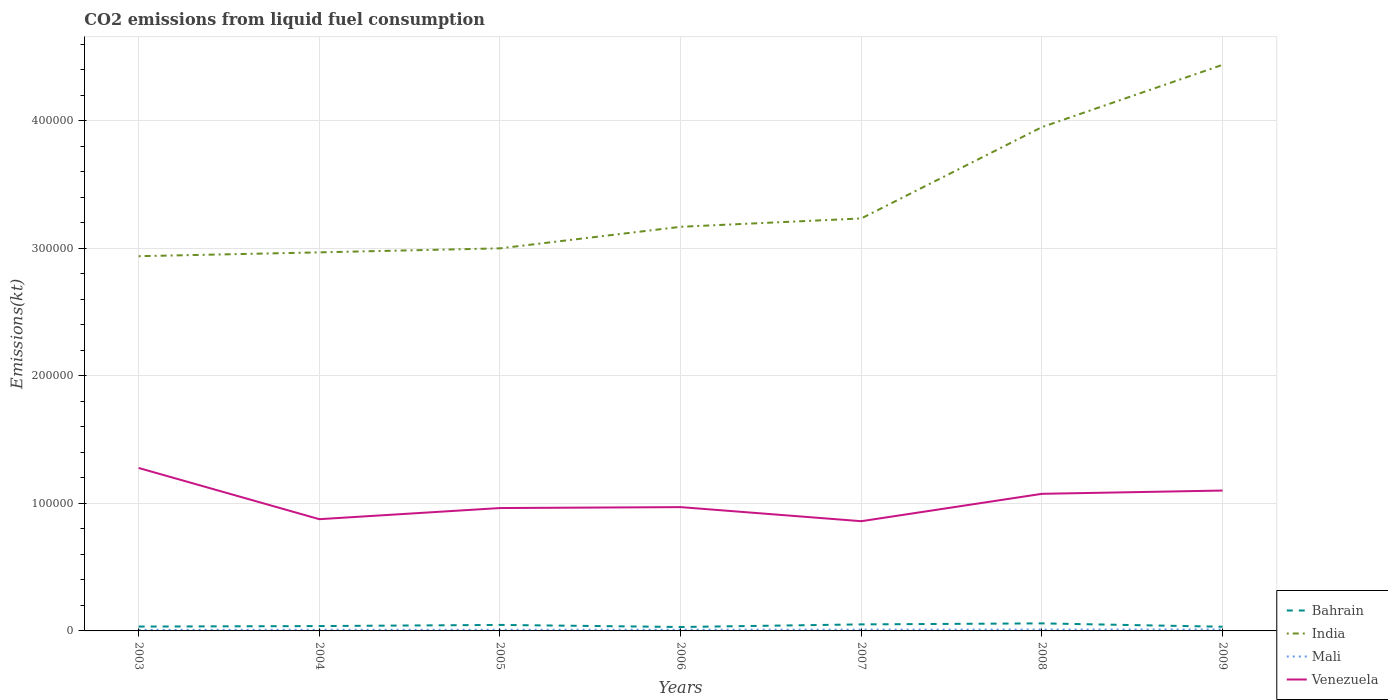How many different coloured lines are there?
Offer a terse response. 4. Does the line corresponding to Bahrain intersect with the line corresponding to Venezuela?
Offer a very short reply. No. Is the number of lines equal to the number of legend labels?
Your answer should be very brief. Yes. Across all years, what is the maximum amount of CO2 emitted in Bahrain?
Make the answer very short. 3072.95. In which year was the amount of CO2 emitted in Venezuela maximum?
Offer a very short reply. 2007. What is the total amount of CO2 emitted in Bahrain in the graph?
Give a very brief answer. 1430.13. What is the difference between the highest and the second highest amount of CO2 emitted in India?
Your answer should be compact. 1.50e+05. What is the difference between the highest and the lowest amount of CO2 emitted in Bahrain?
Provide a succinct answer. 3. Is the amount of CO2 emitted in Mali strictly greater than the amount of CO2 emitted in Venezuela over the years?
Your response must be concise. Yes. How many lines are there?
Keep it short and to the point. 4. How many years are there in the graph?
Provide a succinct answer. 7. Does the graph contain grids?
Your answer should be compact. Yes. Where does the legend appear in the graph?
Offer a terse response. Bottom right. What is the title of the graph?
Provide a short and direct response. CO2 emissions from liquid fuel consumption. What is the label or title of the X-axis?
Offer a terse response. Years. What is the label or title of the Y-axis?
Your response must be concise. Emissions(kt). What is the Emissions(kt) of Bahrain in 2003?
Your answer should be very brief. 3417.64. What is the Emissions(kt) in India in 2003?
Offer a terse response. 2.94e+05. What is the Emissions(kt) of Mali in 2003?
Offer a very short reply. 843.41. What is the Emissions(kt) of Venezuela in 2003?
Provide a succinct answer. 1.28e+05. What is the Emissions(kt) in Bahrain in 2004?
Keep it short and to the point. 3806.35. What is the Emissions(kt) of India in 2004?
Give a very brief answer. 2.97e+05. What is the Emissions(kt) in Mali in 2004?
Your response must be concise. 876.41. What is the Emissions(kt) of Venezuela in 2004?
Your response must be concise. 8.76e+04. What is the Emissions(kt) in Bahrain in 2005?
Keep it short and to the point. 4704.76. What is the Emissions(kt) in India in 2005?
Your answer should be very brief. 3.00e+05. What is the Emissions(kt) of Mali in 2005?
Your answer should be compact. 898.41. What is the Emissions(kt) of Venezuela in 2005?
Offer a very short reply. 9.64e+04. What is the Emissions(kt) in Bahrain in 2006?
Your answer should be very brief. 3072.95. What is the Emissions(kt) of India in 2006?
Your answer should be very brief. 3.17e+05. What is the Emissions(kt) of Mali in 2006?
Provide a succinct answer. 942.42. What is the Emissions(kt) in Venezuela in 2006?
Your response must be concise. 9.71e+04. What is the Emissions(kt) of Bahrain in 2007?
Provide a short and direct response. 5126.47. What is the Emissions(kt) of India in 2007?
Your answer should be compact. 3.23e+05. What is the Emissions(kt) of Mali in 2007?
Give a very brief answer. 1008.42. What is the Emissions(kt) of Venezuela in 2007?
Provide a succinct answer. 8.60e+04. What is the Emissions(kt) of Bahrain in 2008?
Your response must be concise. 5911.2. What is the Emissions(kt) in India in 2008?
Ensure brevity in your answer.  3.95e+05. What is the Emissions(kt) in Mali in 2008?
Ensure brevity in your answer.  1070.76. What is the Emissions(kt) of Venezuela in 2008?
Give a very brief answer. 1.08e+05. What is the Emissions(kt) of Bahrain in 2009?
Offer a terse response. 3274.63. What is the Emissions(kt) in India in 2009?
Offer a terse response. 4.44e+05. What is the Emissions(kt) of Mali in 2009?
Your answer should be compact. 1147.77. What is the Emissions(kt) in Venezuela in 2009?
Make the answer very short. 1.10e+05. Across all years, what is the maximum Emissions(kt) of Bahrain?
Give a very brief answer. 5911.2. Across all years, what is the maximum Emissions(kt) in India?
Your answer should be very brief. 4.44e+05. Across all years, what is the maximum Emissions(kt) of Mali?
Your answer should be compact. 1147.77. Across all years, what is the maximum Emissions(kt) of Venezuela?
Ensure brevity in your answer.  1.28e+05. Across all years, what is the minimum Emissions(kt) of Bahrain?
Make the answer very short. 3072.95. Across all years, what is the minimum Emissions(kt) in India?
Provide a short and direct response. 2.94e+05. Across all years, what is the minimum Emissions(kt) in Mali?
Offer a very short reply. 843.41. Across all years, what is the minimum Emissions(kt) of Venezuela?
Keep it short and to the point. 8.60e+04. What is the total Emissions(kt) of Bahrain in the graph?
Give a very brief answer. 2.93e+04. What is the total Emissions(kt) in India in the graph?
Offer a terse response. 2.37e+06. What is the total Emissions(kt) in Mali in the graph?
Your answer should be compact. 6787.62. What is the total Emissions(kt) in Venezuela in the graph?
Ensure brevity in your answer.  7.13e+05. What is the difference between the Emissions(kt) of Bahrain in 2003 and that in 2004?
Offer a terse response. -388.7. What is the difference between the Emissions(kt) in India in 2003 and that in 2004?
Provide a succinct answer. -3006.94. What is the difference between the Emissions(kt) of Mali in 2003 and that in 2004?
Offer a terse response. -33. What is the difference between the Emissions(kt) of Venezuela in 2003 and that in 2004?
Make the answer very short. 4.02e+04. What is the difference between the Emissions(kt) in Bahrain in 2003 and that in 2005?
Provide a succinct answer. -1287.12. What is the difference between the Emissions(kt) of India in 2003 and that in 2005?
Give a very brief answer. -6160.56. What is the difference between the Emissions(kt) of Mali in 2003 and that in 2005?
Make the answer very short. -55.01. What is the difference between the Emissions(kt) of Venezuela in 2003 and that in 2005?
Your response must be concise. 3.14e+04. What is the difference between the Emissions(kt) in Bahrain in 2003 and that in 2006?
Provide a succinct answer. 344.7. What is the difference between the Emissions(kt) in India in 2003 and that in 2006?
Your answer should be compact. -2.31e+04. What is the difference between the Emissions(kt) in Mali in 2003 and that in 2006?
Your answer should be compact. -99.01. What is the difference between the Emissions(kt) in Venezuela in 2003 and that in 2006?
Offer a terse response. 3.07e+04. What is the difference between the Emissions(kt) of Bahrain in 2003 and that in 2007?
Make the answer very short. -1708.82. What is the difference between the Emissions(kt) of India in 2003 and that in 2007?
Keep it short and to the point. -2.96e+04. What is the difference between the Emissions(kt) of Mali in 2003 and that in 2007?
Your answer should be very brief. -165.01. What is the difference between the Emissions(kt) of Venezuela in 2003 and that in 2007?
Give a very brief answer. 4.17e+04. What is the difference between the Emissions(kt) of Bahrain in 2003 and that in 2008?
Your answer should be very brief. -2493.56. What is the difference between the Emissions(kt) in India in 2003 and that in 2008?
Offer a terse response. -1.01e+05. What is the difference between the Emissions(kt) in Mali in 2003 and that in 2008?
Offer a terse response. -227.35. What is the difference between the Emissions(kt) of Venezuela in 2003 and that in 2008?
Your answer should be compact. 2.03e+04. What is the difference between the Emissions(kt) of Bahrain in 2003 and that in 2009?
Give a very brief answer. 143.01. What is the difference between the Emissions(kt) of India in 2003 and that in 2009?
Ensure brevity in your answer.  -1.50e+05. What is the difference between the Emissions(kt) in Mali in 2003 and that in 2009?
Offer a very short reply. -304.36. What is the difference between the Emissions(kt) in Venezuela in 2003 and that in 2009?
Ensure brevity in your answer.  1.77e+04. What is the difference between the Emissions(kt) in Bahrain in 2004 and that in 2005?
Offer a very short reply. -898.41. What is the difference between the Emissions(kt) of India in 2004 and that in 2005?
Your answer should be compact. -3153.62. What is the difference between the Emissions(kt) of Mali in 2004 and that in 2005?
Make the answer very short. -22. What is the difference between the Emissions(kt) in Venezuela in 2004 and that in 2005?
Give a very brief answer. -8731.13. What is the difference between the Emissions(kt) of Bahrain in 2004 and that in 2006?
Offer a terse response. 733.4. What is the difference between the Emissions(kt) in India in 2004 and that in 2006?
Keep it short and to the point. -2.00e+04. What is the difference between the Emissions(kt) of Mali in 2004 and that in 2006?
Offer a terse response. -66.01. What is the difference between the Emissions(kt) of Venezuela in 2004 and that in 2006?
Ensure brevity in your answer.  -9453.53. What is the difference between the Emissions(kt) in Bahrain in 2004 and that in 2007?
Provide a short and direct response. -1320.12. What is the difference between the Emissions(kt) of India in 2004 and that in 2007?
Provide a short and direct response. -2.66e+04. What is the difference between the Emissions(kt) of Mali in 2004 and that in 2007?
Provide a succinct answer. -132.01. What is the difference between the Emissions(kt) in Venezuela in 2004 and that in 2007?
Offer a terse response. 1587.81. What is the difference between the Emissions(kt) of Bahrain in 2004 and that in 2008?
Give a very brief answer. -2104.86. What is the difference between the Emissions(kt) of India in 2004 and that in 2008?
Ensure brevity in your answer.  -9.82e+04. What is the difference between the Emissions(kt) of Mali in 2004 and that in 2008?
Give a very brief answer. -194.35. What is the difference between the Emissions(kt) in Venezuela in 2004 and that in 2008?
Give a very brief answer. -1.99e+04. What is the difference between the Emissions(kt) of Bahrain in 2004 and that in 2009?
Ensure brevity in your answer.  531.72. What is the difference between the Emissions(kt) of India in 2004 and that in 2009?
Offer a terse response. -1.47e+05. What is the difference between the Emissions(kt) in Mali in 2004 and that in 2009?
Ensure brevity in your answer.  -271.36. What is the difference between the Emissions(kt) in Venezuela in 2004 and that in 2009?
Provide a short and direct response. -2.25e+04. What is the difference between the Emissions(kt) in Bahrain in 2005 and that in 2006?
Your response must be concise. 1631.82. What is the difference between the Emissions(kt) of India in 2005 and that in 2006?
Offer a terse response. -1.69e+04. What is the difference between the Emissions(kt) in Mali in 2005 and that in 2006?
Offer a terse response. -44. What is the difference between the Emissions(kt) of Venezuela in 2005 and that in 2006?
Offer a very short reply. -722.4. What is the difference between the Emissions(kt) of Bahrain in 2005 and that in 2007?
Offer a terse response. -421.7. What is the difference between the Emissions(kt) of India in 2005 and that in 2007?
Provide a short and direct response. -2.34e+04. What is the difference between the Emissions(kt) of Mali in 2005 and that in 2007?
Keep it short and to the point. -110.01. What is the difference between the Emissions(kt) in Venezuela in 2005 and that in 2007?
Your answer should be compact. 1.03e+04. What is the difference between the Emissions(kt) in Bahrain in 2005 and that in 2008?
Your answer should be very brief. -1206.44. What is the difference between the Emissions(kt) in India in 2005 and that in 2008?
Make the answer very short. -9.51e+04. What is the difference between the Emissions(kt) of Mali in 2005 and that in 2008?
Your answer should be very brief. -172.35. What is the difference between the Emissions(kt) in Venezuela in 2005 and that in 2008?
Your answer should be very brief. -1.12e+04. What is the difference between the Emissions(kt) in Bahrain in 2005 and that in 2009?
Give a very brief answer. 1430.13. What is the difference between the Emissions(kt) of India in 2005 and that in 2009?
Offer a terse response. -1.44e+05. What is the difference between the Emissions(kt) of Mali in 2005 and that in 2009?
Ensure brevity in your answer.  -249.36. What is the difference between the Emissions(kt) in Venezuela in 2005 and that in 2009?
Ensure brevity in your answer.  -1.37e+04. What is the difference between the Emissions(kt) in Bahrain in 2006 and that in 2007?
Your response must be concise. -2053.52. What is the difference between the Emissions(kt) in India in 2006 and that in 2007?
Give a very brief answer. -6549.26. What is the difference between the Emissions(kt) in Mali in 2006 and that in 2007?
Ensure brevity in your answer.  -66.01. What is the difference between the Emissions(kt) in Venezuela in 2006 and that in 2007?
Offer a terse response. 1.10e+04. What is the difference between the Emissions(kt) of Bahrain in 2006 and that in 2008?
Give a very brief answer. -2838.26. What is the difference between the Emissions(kt) in India in 2006 and that in 2008?
Your answer should be compact. -7.82e+04. What is the difference between the Emissions(kt) of Mali in 2006 and that in 2008?
Offer a very short reply. -128.34. What is the difference between the Emissions(kt) of Venezuela in 2006 and that in 2008?
Give a very brief answer. -1.04e+04. What is the difference between the Emissions(kt) of Bahrain in 2006 and that in 2009?
Your answer should be compact. -201.69. What is the difference between the Emissions(kt) in India in 2006 and that in 2009?
Your answer should be very brief. -1.27e+05. What is the difference between the Emissions(kt) of Mali in 2006 and that in 2009?
Offer a terse response. -205.35. What is the difference between the Emissions(kt) of Venezuela in 2006 and that in 2009?
Keep it short and to the point. -1.30e+04. What is the difference between the Emissions(kt) of Bahrain in 2007 and that in 2008?
Give a very brief answer. -784.74. What is the difference between the Emissions(kt) of India in 2007 and that in 2008?
Ensure brevity in your answer.  -7.16e+04. What is the difference between the Emissions(kt) of Mali in 2007 and that in 2008?
Your answer should be very brief. -62.34. What is the difference between the Emissions(kt) in Venezuela in 2007 and that in 2008?
Ensure brevity in your answer.  -2.15e+04. What is the difference between the Emissions(kt) in Bahrain in 2007 and that in 2009?
Offer a very short reply. 1851.84. What is the difference between the Emissions(kt) in India in 2007 and that in 2009?
Provide a short and direct response. -1.20e+05. What is the difference between the Emissions(kt) of Mali in 2007 and that in 2009?
Offer a terse response. -139.35. What is the difference between the Emissions(kt) in Venezuela in 2007 and that in 2009?
Your answer should be very brief. -2.40e+04. What is the difference between the Emissions(kt) in Bahrain in 2008 and that in 2009?
Your response must be concise. 2636.57. What is the difference between the Emissions(kt) in India in 2008 and that in 2009?
Provide a succinct answer. -4.88e+04. What is the difference between the Emissions(kt) in Mali in 2008 and that in 2009?
Your answer should be compact. -77.01. What is the difference between the Emissions(kt) of Venezuela in 2008 and that in 2009?
Make the answer very short. -2570.57. What is the difference between the Emissions(kt) in Bahrain in 2003 and the Emissions(kt) in India in 2004?
Your response must be concise. -2.93e+05. What is the difference between the Emissions(kt) of Bahrain in 2003 and the Emissions(kt) of Mali in 2004?
Your answer should be compact. 2541.23. What is the difference between the Emissions(kt) of Bahrain in 2003 and the Emissions(kt) of Venezuela in 2004?
Make the answer very short. -8.42e+04. What is the difference between the Emissions(kt) of India in 2003 and the Emissions(kt) of Mali in 2004?
Your answer should be compact. 2.93e+05. What is the difference between the Emissions(kt) in India in 2003 and the Emissions(kt) in Venezuela in 2004?
Offer a terse response. 2.06e+05. What is the difference between the Emissions(kt) in Mali in 2003 and the Emissions(kt) in Venezuela in 2004?
Offer a very short reply. -8.68e+04. What is the difference between the Emissions(kt) of Bahrain in 2003 and the Emissions(kt) of India in 2005?
Offer a terse response. -2.97e+05. What is the difference between the Emissions(kt) in Bahrain in 2003 and the Emissions(kt) in Mali in 2005?
Provide a succinct answer. 2519.23. What is the difference between the Emissions(kt) in Bahrain in 2003 and the Emissions(kt) in Venezuela in 2005?
Keep it short and to the point. -9.29e+04. What is the difference between the Emissions(kt) in India in 2003 and the Emissions(kt) in Mali in 2005?
Your answer should be compact. 2.93e+05. What is the difference between the Emissions(kt) of India in 2003 and the Emissions(kt) of Venezuela in 2005?
Your answer should be very brief. 1.97e+05. What is the difference between the Emissions(kt) of Mali in 2003 and the Emissions(kt) of Venezuela in 2005?
Provide a succinct answer. -9.55e+04. What is the difference between the Emissions(kt) of Bahrain in 2003 and the Emissions(kt) of India in 2006?
Ensure brevity in your answer.  -3.13e+05. What is the difference between the Emissions(kt) of Bahrain in 2003 and the Emissions(kt) of Mali in 2006?
Make the answer very short. 2475.22. What is the difference between the Emissions(kt) in Bahrain in 2003 and the Emissions(kt) in Venezuela in 2006?
Give a very brief answer. -9.37e+04. What is the difference between the Emissions(kt) of India in 2003 and the Emissions(kt) of Mali in 2006?
Keep it short and to the point. 2.93e+05. What is the difference between the Emissions(kt) of India in 2003 and the Emissions(kt) of Venezuela in 2006?
Make the answer very short. 1.97e+05. What is the difference between the Emissions(kt) in Mali in 2003 and the Emissions(kt) in Venezuela in 2006?
Your response must be concise. -9.62e+04. What is the difference between the Emissions(kt) of Bahrain in 2003 and the Emissions(kt) of India in 2007?
Make the answer very short. -3.20e+05. What is the difference between the Emissions(kt) of Bahrain in 2003 and the Emissions(kt) of Mali in 2007?
Your answer should be very brief. 2409.22. What is the difference between the Emissions(kt) in Bahrain in 2003 and the Emissions(kt) in Venezuela in 2007?
Give a very brief answer. -8.26e+04. What is the difference between the Emissions(kt) in India in 2003 and the Emissions(kt) in Mali in 2007?
Offer a very short reply. 2.93e+05. What is the difference between the Emissions(kt) in India in 2003 and the Emissions(kt) in Venezuela in 2007?
Offer a very short reply. 2.08e+05. What is the difference between the Emissions(kt) in Mali in 2003 and the Emissions(kt) in Venezuela in 2007?
Your answer should be compact. -8.52e+04. What is the difference between the Emissions(kt) of Bahrain in 2003 and the Emissions(kt) of India in 2008?
Your answer should be compact. -3.92e+05. What is the difference between the Emissions(kt) in Bahrain in 2003 and the Emissions(kt) in Mali in 2008?
Ensure brevity in your answer.  2346.88. What is the difference between the Emissions(kt) in Bahrain in 2003 and the Emissions(kt) in Venezuela in 2008?
Your response must be concise. -1.04e+05. What is the difference between the Emissions(kt) in India in 2003 and the Emissions(kt) in Mali in 2008?
Your answer should be very brief. 2.93e+05. What is the difference between the Emissions(kt) in India in 2003 and the Emissions(kt) in Venezuela in 2008?
Ensure brevity in your answer.  1.86e+05. What is the difference between the Emissions(kt) in Mali in 2003 and the Emissions(kt) in Venezuela in 2008?
Give a very brief answer. -1.07e+05. What is the difference between the Emissions(kt) in Bahrain in 2003 and the Emissions(kt) in India in 2009?
Offer a terse response. -4.41e+05. What is the difference between the Emissions(kt) of Bahrain in 2003 and the Emissions(kt) of Mali in 2009?
Your answer should be compact. 2269.87. What is the difference between the Emissions(kt) in Bahrain in 2003 and the Emissions(kt) in Venezuela in 2009?
Offer a very short reply. -1.07e+05. What is the difference between the Emissions(kt) in India in 2003 and the Emissions(kt) in Mali in 2009?
Give a very brief answer. 2.93e+05. What is the difference between the Emissions(kt) of India in 2003 and the Emissions(kt) of Venezuela in 2009?
Offer a very short reply. 1.84e+05. What is the difference between the Emissions(kt) of Mali in 2003 and the Emissions(kt) of Venezuela in 2009?
Provide a succinct answer. -1.09e+05. What is the difference between the Emissions(kt) of Bahrain in 2004 and the Emissions(kt) of India in 2005?
Your answer should be very brief. -2.96e+05. What is the difference between the Emissions(kt) of Bahrain in 2004 and the Emissions(kt) of Mali in 2005?
Your answer should be compact. 2907.93. What is the difference between the Emissions(kt) in Bahrain in 2004 and the Emissions(kt) in Venezuela in 2005?
Offer a terse response. -9.26e+04. What is the difference between the Emissions(kt) in India in 2004 and the Emissions(kt) in Mali in 2005?
Provide a short and direct response. 2.96e+05. What is the difference between the Emissions(kt) in India in 2004 and the Emissions(kt) in Venezuela in 2005?
Give a very brief answer. 2.00e+05. What is the difference between the Emissions(kt) in Mali in 2004 and the Emissions(kt) in Venezuela in 2005?
Provide a short and direct response. -9.55e+04. What is the difference between the Emissions(kt) in Bahrain in 2004 and the Emissions(kt) in India in 2006?
Provide a succinct answer. -3.13e+05. What is the difference between the Emissions(kt) of Bahrain in 2004 and the Emissions(kt) of Mali in 2006?
Ensure brevity in your answer.  2863.93. What is the difference between the Emissions(kt) in Bahrain in 2004 and the Emissions(kt) in Venezuela in 2006?
Your answer should be very brief. -9.33e+04. What is the difference between the Emissions(kt) of India in 2004 and the Emissions(kt) of Mali in 2006?
Your answer should be very brief. 2.96e+05. What is the difference between the Emissions(kt) of India in 2004 and the Emissions(kt) of Venezuela in 2006?
Make the answer very short. 2.00e+05. What is the difference between the Emissions(kt) in Mali in 2004 and the Emissions(kt) in Venezuela in 2006?
Your response must be concise. -9.62e+04. What is the difference between the Emissions(kt) in Bahrain in 2004 and the Emissions(kt) in India in 2007?
Your response must be concise. -3.20e+05. What is the difference between the Emissions(kt) of Bahrain in 2004 and the Emissions(kt) of Mali in 2007?
Ensure brevity in your answer.  2797.92. What is the difference between the Emissions(kt) of Bahrain in 2004 and the Emissions(kt) of Venezuela in 2007?
Offer a very short reply. -8.22e+04. What is the difference between the Emissions(kt) in India in 2004 and the Emissions(kt) in Mali in 2007?
Give a very brief answer. 2.96e+05. What is the difference between the Emissions(kt) in India in 2004 and the Emissions(kt) in Venezuela in 2007?
Offer a very short reply. 2.11e+05. What is the difference between the Emissions(kt) of Mali in 2004 and the Emissions(kt) of Venezuela in 2007?
Provide a short and direct response. -8.52e+04. What is the difference between the Emissions(kt) in Bahrain in 2004 and the Emissions(kt) in India in 2008?
Give a very brief answer. -3.91e+05. What is the difference between the Emissions(kt) of Bahrain in 2004 and the Emissions(kt) of Mali in 2008?
Your answer should be compact. 2735.58. What is the difference between the Emissions(kt) of Bahrain in 2004 and the Emissions(kt) of Venezuela in 2008?
Offer a terse response. -1.04e+05. What is the difference between the Emissions(kt) in India in 2004 and the Emissions(kt) in Mali in 2008?
Ensure brevity in your answer.  2.96e+05. What is the difference between the Emissions(kt) of India in 2004 and the Emissions(kt) of Venezuela in 2008?
Your answer should be very brief. 1.89e+05. What is the difference between the Emissions(kt) in Mali in 2004 and the Emissions(kt) in Venezuela in 2008?
Your answer should be very brief. -1.07e+05. What is the difference between the Emissions(kt) of Bahrain in 2004 and the Emissions(kt) of India in 2009?
Give a very brief answer. -4.40e+05. What is the difference between the Emissions(kt) in Bahrain in 2004 and the Emissions(kt) in Mali in 2009?
Offer a terse response. 2658.57. What is the difference between the Emissions(kt) in Bahrain in 2004 and the Emissions(kt) in Venezuela in 2009?
Provide a short and direct response. -1.06e+05. What is the difference between the Emissions(kt) of India in 2004 and the Emissions(kt) of Mali in 2009?
Your answer should be very brief. 2.96e+05. What is the difference between the Emissions(kt) of India in 2004 and the Emissions(kt) of Venezuela in 2009?
Provide a succinct answer. 1.87e+05. What is the difference between the Emissions(kt) in Mali in 2004 and the Emissions(kt) in Venezuela in 2009?
Provide a short and direct response. -1.09e+05. What is the difference between the Emissions(kt) of Bahrain in 2005 and the Emissions(kt) of India in 2006?
Your response must be concise. -3.12e+05. What is the difference between the Emissions(kt) of Bahrain in 2005 and the Emissions(kt) of Mali in 2006?
Make the answer very short. 3762.34. What is the difference between the Emissions(kt) in Bahrain in 2005 and the Emissions(kt) in Venezuela in 2006?
Your answer should be compact. -9.24e+04. What is the difference between the Emissions(kt) of India in 2005 and the Emissions(kt) of Mali in 2006?
Provide a short and direct response. 2.99e+05. What is the difference between the Emissions(kt) in India in 2005 and the Emissions(kt) in Venezuela in 2006?
Offer a very short reply. 2.03e+05. What is the difference between the Emissions(kt) of Mali in 2005 and the Emissions(kt) of Venezuela in 2006?
Your answer should be very brief. -9.62e+04. What is the difference between the Emissions(kt) of Bahrain in 2005 and the Emissions(kt) of India in 2007?
Your answer should be compact. -3.19e+05. What is the difference between the Emissions(kt) in Bahrain in 2005 and the Emissions(kt) in Mali in 2007?
Keep it short and to the point. 3696.34. What is the difference between the Emissions(kt) in Bahrain in 2005 and the Emissions(kt) in Venezuela in 2007?
Provide a short and direct response. -8.13e+04. What is the difference between the Emissions(kt) of India in 2005 and the Emissions(kt) of Mali in 2007?
Make the answer very short. 2.99e+05. What is the difference between the Emissions(kt) of India in 2005 and the Emissions(kt) of Venezuela in 2007?
Provide a succinct answer. 2.14e+05. What is the difference between the Emissions(kt) in Mali in 2005 and the Emissions(kt) in Venezuela in 2007?
Offer a terse response. -8.51e+04. What is the difference between the Emissions(kt) of Bahrain in 2005 and the Emissions(kt) of India in 2008?
Offer a very short reply. -3.90e+05. What is the difference between the Emissions(kt) in Bahrain in 2005 and the Emissions(kt) in Mali in 2008?
Make the answer very short. 3634. What is the difference between the Emissions(kt) of Bahrain in 2005 and the Emissions(kt) of Venezuela in 2008?
Ensure brevity in your answer.  -1.03e+05. What is the difference between the Emissions(kt) of India in 2005 and the Emissions(kt) of Mali in 2008?
Give a very brief answer. 2.99e+05. What is the difference between the Emissions(kt) in India in 2005 and the Emissions(kt) in Venezuela in 2008?
Give a very brief answer. 1.92e+05. What is the difference between the Emissions(kt) of Mali in 2005 and the Emissions(kt) of Venezuela in 2008?
Your response must be concise. -1.07e+05. What is the difference between the Emissions(kt) in Bahrain in 2005 and the Emissions(kt) in India in 2009?
Ensure brevity in your answer.  -4.39e+05. What is the difference between the Emissions(kt) in Bahrain in 2005 and the Emissions(kt) in Mali in 2009?
Provide a succinct answer. 3556.99. What is the difference between the Emissions(kt) of Bahrain in 2005 and the Emissions(kt) of Venezuela in 2009?
Your answer should be compact. -1.05e+05. What is the difference between the Emissions(kt) of India in 2005 and the Emissions(kt) of Mali in 2009?
Provide a short and direct response. 2.99e+05. What is the difference between the Emissions(kt) in India in 2005 and the Emissions(kt) in Venezuela in 2009?
Your response must be concise. 1.90e+05. What is the difference between the Emissions(kt) of Mali in 2005 and the Emissions(kt) of Venezuela in 2009?
Ensure brevity in your answer.  -1.09e+05. What is the difference between the Emissions(kt) in Bahrain in 2006 and the Emissions(kt) in India in 2007?
Provide a succinct answer. -3.20e+05. What is the difference between the Emissions(kt) of Bahrain in 2006 and the Emissions(kt) of Mali in 2007?
Make the answer very short. 2064.52. What is the difference between the Emissions(kt) of Bahrain in 2006 and the Emissions(kt) of Venezuela in 2007?
Keep it short and to the point. -8.30e+04. What is the difference between the Emissions(kt) of India in 2006 and the Emissions(kt) of Mali in 2007?
Keep it short and to the point. 3.16e+05. What is the difference between the Emissions(kt) of India in 2006 and the Emissions(kt) of Venezuela in 2007?
Provide a succinct answer. 2.31e+05. What is the difference between the Emissions(kt) in Mali in 2006 and the Emissions(kt) in Venezuela in 2007?
Keep it short and to the point. -8.51e+04. What is the difference between the Emissions(kt) in Bahrain in 2006 and the Emissions(kt) in India in 2008?
Offer a terse response. -3.92e+05. What is the difference between the Emissions(kt) in Bahrain in 2006 and the Emissions(kt) in Mali in 2008?
Give a very brief answer. 2002.18. What is the difference between the Emissions(kt) of Bahrain in 2006 and the Emissions(kt) of Venezuela in 2008?
Make the answer very short. -1.04e+05. What is the difference between the Emissions(kt) of India in 2006 and the Emissions(kt) of Mali in 2008?
Your response must be concise. 3.16e+05. What is the difference between the Emissions(kt) of India in 2006 and the Emissions(kt) of Venezuela in 2008?
Your answer should be very brief. 2.09e+05. What is the difference between the Emissions(kt) of Mali in 2006 and the Emissions(kt) of Venezuela in 2008?
Your answer should be compact. -1.07e+05. What is the difference between the Emissions(kt) of Bahrain in 2006 and the Emissions(kt) of India in 2009?
Keep it short and to the point. -4.41e+05. What is the difference between the Emissions(kt) of Bahrain in 2006 and the Emissions(kt) of Mali in 2009?
Provide a short and direct response. 1925.17. What is the difference between the Emissions(kt) in Bahrain in 2006 and the Emissions(kt) in Venezuela in 2009?
Your answer should be compact. -1.07e+05. What is the difference between the Emissions(kt) in India in 2006 and the Emissions(kt) in Mali in 2009?
Offer a terse response. 3.16e+05. What is the difference between the Emissions(kt) in India in 2006 and the Emissions(kt) in Venezuela in 2009?
Give a very brief answer. 2.07e+05. What is the difference between the Emissions(kt) of Mali in 2006 and the Emissions(kt) of Venezuela in 2009?
Your answer should be compact. -1.09e+05. What is the difference between the Emissions(kt) of Bahrain in 2007 and the Emissions(kt) of India in 2008?
Your answer should be compact. -3.90e+05. What is the difference between the Emissions(kt) of Bahrain in 2007 and the Emissions(kt) of Mali in 2008?
Offer a very short reply. 4055.7. What is the difference between the Emissions(kt) in Bahrain in 2007 and the Emissions(kt) in Venezuela in 2008?
Your response must be concise. -1.02e+05. What is the difference between the Emissions(kt) of India in 2007 and the Emissions(kt) of Mali in 2008?
Ensure brevity in your answer.  3.22e+05. What is the difference between the Emissions(kt) of India in 2007 and the Emissions(kt) of Venezuela in 2008?
Keep it short and to the point. 2.16e+05. What is the difference between the Emissions(kt) in Mali in 2007 and the Emissions(kt) in Venezuela in 2008?
Your answer should be compact. -1.07e+05. What is the difference between the Emissions(kt) in Bahrain in 2007 and the Emissions(kt) in India in 2009?
Provide a short and direct response. -4.39e+05. What is the difference between the Emissions(kt) of Bahrain in 2007 and the Emissions(kt) of Mali in 2009?
Offer a very short reply. 3978.7. What is the difference between the Emissions(kt) in Bahrain in 2007 and the Emissions(kt) in Venezuela in 2009?
Give a very brief answer. -1.05e+05. What is the difference between the Emissions(kt) of India in 2007 and the Emissions(kt) of Mali in 2009?
Provide a succinct answer. 3.22e+05. What is the difference between the Emissions(kt) in India in 2007 and the Emissions(kt) in Venezuela in 2009?
Offer a terse response. 2.13e+05. What is the difference between the Emissions(kt) of Mali in 2007 and the Emissions(kt) of Venezuela in 2009?
Provide a succinct answer. -1.09e+05. What is the difference between the Emissions(kt) in Bahrain in 2008 and the Emissions(kt) in India in 2009?
Your response must be concise. -4.38e+05. What is the difference between the Emissions(kt) of Bahrain in 2008 and the Emissions(kt) of Mali in 2009?
Give a very brief answer. 4763.43. What is the difference between the Emissions(kt) of Bahrain in 2008 and the Emissions(kt) of Venezuela in 2009?
Keep it short and to the point. -1.04e+05. What is the difference between the Emissions(kt) in India in 2008 and the Emissions(kt) in Mali in 2009?
Provide a succinct answer. 3.94e+05. What is the difference between the Emissions(kt) of India in 2008 and the Emissions(kt) of Venezuela in 2009?
Your answer should be very brief. 2.85e+05. What is the difference between the Emissions(kt) of Mali in 2008 and the Emissions(kt) of Venezuela in 2009?
Provide a short and direct response. -1.09e+05. What is the average Emissions(kt) in Bahrain per year?
Offer a very short reply. 4187.71. What is the average Emissions(kt) of India per year?
Keep it short and to the point. 3.39e+05. What is the average Emissions(kt) in Mali per year?
Offer a very short reply. 969.66. What is the average Emissions(kt) of Venezuela per year?
Offer a terse response. 1.02e+05. In the year 2003, what is the difference between the Emissions(kt) in Bahrain and Emissions(kt) in India?
Make the answer very short. -2.90e+05. In the year 2003, what is the difference between the Emissions(kt) in Bahrain and Emissions(kt) in Mali?
Make the answer very short. 2574.23. In the year 2003, what is the difference between the Emissions(kt) of Bahrain and Emissions(kt) of Venezuela?
Make the answer very short. -1.24e+05. In the year 2003, what is the difference between the Emissions(kt) of India and Emissions(kt) of Mali?
Your response must be concise. 2.93e+05. In the year 2003, what is the difference between the Emissions(kt) in India and Emissions(kt) in Venezuela?
Keep it short and to the point. 1.66e+05. In the year 2003, what is the difference between the Emissions(kt) in Mali and Emissions(kt) in Venezuela?
Provide a succinct answer. -1.27e+05. In the year 2004, what is the difference between the Emissions(kt) of Bahrain and Emissions(kt) of India?
Offer a terse response. -2.93e+05. In the year 2004, what is the difference between the Emissions(kt) of Bahrain and Emissions(kt) of Mali?
Keep it short and to the point. 2929.93. In the year 2004, what is the difference between the Emissions(kt) of Bahrain and Emissions(kt) of Venezuela?
Give a very brief answer. -8.38e+04. In the year 2004, what is the difference between the Emissions(kt) of India and Emissions(kt) of Mali?
Offer a terse response. 2.96e+05. In the year 2004, what is the difference between the Emissions(kt) in India and Emissions(kt) in Venezuela?
Offer a very short reply. 2.09e+05. In the year 2004, what is the difference between the Emissions(kt) of Mali and Emissions(kt) of Venezuela?
Your response must be concise. -8.68e+04. In the year 2005, what is the difference between the Emissions(kt) of Bahrain and Emissions(kt) of India?
Give a very brief answer. -2.95e+05. In the year 2005, what is the difference between the Emissions(kt) in Bahrain and Emissions(kt) in Mali?
Offer a terse response. 3806.35. In the year 2005, what is the difference between the Emissions(kt) in Bahrain and Emissions(kt) in Venezuela?
Offer a terse response. -9.17e+04. In the year 2005, what is the difference between the Emissions(kt) in India and Emissions(kt) in Mali?
Offer a very short reply. 2.99e+05. In the year 2005, what is the difference between the Emissions(kt) of India and Emissions(kt) of Venezuela?
Offer a terse response. 2.04e+05. In the year 2005, what is the difference between the Emissions(kt) in Mali and Emissions(kt) in Venezuela?
Provide a short and direct response. -9.55e+04. In the year 2006, what is the difference between the Emissions(kt) of Bahrain and Emissions(kt) of India?
Keep it short and to the point. -3.14e+05. In the year 2006, what is the difference between the Emissions(kt) of Bahrain and Emissions(kt) of Mali?
Offer a terse response. 2130.53. In the year 2006, what is the difference between the Emissions(kt) of Bahrain and Emissions(kt) of Venezuela?
Your answer should be compact. -9.40e+04. In the year 2006, what is the difference between the Emissions(kt) of India and Emissions(kt) of Mali?
Keep it short and to the point. 3.16e+05. In the year 2006, what is the difference between the Emissions(kt) in India and Emissions(kt) in Venezuela?
Offer a very short reply. 2.20e+05. In the year 2006, what is the difference between the Emissions(kt) of Mali and Emissions(kt) of Venezuela?
Make the answer very short. -9.61e+04. In the year 2007, what is the difference between the Emissions(kt) in Bahrain and Emissions(kt) in India?
Make the answer very short. -3.18e+05. In the year 2007, what is the difference between the Emissions(kt) of Bahrain and Emissions(kt) of Mali?
Offer a terse response. 4118.04. In the year 2007, what is the difference between the Emissions(kt) of Bahrain and Emissions(kt) of Venezuela?
Your answer should be very brief. -8.09e+04. In the year 2007, what is the difference between the Emissions(kt) of India and Emissions(kt) of Mali?
Offer a terse response. 3.22e+05. In the year 2007, what is the difference between the Emissions(kt) of India and Emissions(kt) of Venezuela?
Give a very brief answer. 2.37e+05. In the year 2007, what is the difference between the Emissions(kt) of Mali and Emissions(kt) of Venezuela?
Your answer should be compact. -8.50e+04. In the year 2008, what is the difference between the Emissions(kt) in Bahrain and Emissions(kt) in India?
Ensure brevity in your answer.  -3.89e+05. In the year 2008, what is the difference between the Emissions(kt) of Bahrain and Emissions(kt) of Mali?
Provide a short and direct response. 4840.44. In the year 2008, what is the difference between the Emissions(kt) in Bahrain and Emissions(kt) in Venezuela?
Give a very brief answer. -1.02e+05. In the year 2008, what is the difference between the Emissions(kt) in India and Emissions(kt) in Mali?
Your answer should be compact. 3.94e+05. In the year 2008, what is the difference between the Emissions(kt) in India and Emissions(kt) in Venezuela?
Your response must be concise. 2.88e+05. In the year 2008, what is the difference between the Emissions(kt) in Mali and Emissions(kt) in Venezuela?
Keep it short and to the point. -1.06e+05. In the year 2009, what is the difference between the Emissions(kt) in Bahrain and Emissions(kt) in India?
Keep it short and to the point. -4.41e+05. In the year 2009, what is the difference between the Emissions(kt) in Bahrain and Emissions(kt) in Mali?
Offer a very short reply. 2126.86. In the year 2009, what is the difference between the Emissions(kt) of Bahrain and Emissions(kt) of Venezuela?
Your answer should be compact. -1.07e+05. In the year 2009, what is the difference between the Emissions(kt) of India and Emissions(kt) of Mali?
Your answer should be very brief. 4.43e+05. In the year 2009, what is the difference between the Emissions(kt) of India and Emissions(kt) of Venezuela?
Your answer should be compact. 3.34e+05. In the year 2009, what is the difference between the Emissions(kt) of Mali and Emissions(kt) of Venezuela?
Give a very brief answer. -1.09e+05. What is the ratio of the Emissions(kt) in Bahrain in 2003 to that in 2004?
Your answer should be compact. 0.9. What is the ratio of the Emissions(kt) in Mali in 2003 to that in 2004?
Offer a very short reply. 0.96. What is the ratio of the Emissions(kt) in Venezuela in 2003 to that in 2004?
Your answer should be very brief. 1.46. What is the ratio of the Emissions(kt) in Bahrain in 2003 to that in 2005?
Your answer should be very brief. 0.73. What is the ratio of the Emissions(kt) in India in 2003 to that in 2005?
Ensure brevity in your answer.  0.98. What is the ratio of the Emissions(kt) in Mali in 2003 to that in 2005?
Provide a short and direct response. 0.94. What is the ratio of the Emissions(kt) of Venezuela in 2003 to that in 2005?
Make the answer very short. 1.33. What is the ratio of the Emissions(kt) in Bahrain in 2003 to that in 2006?
Offer a very short reply. 1.11. What is the ratio of the Emissions(kt) in India in 2003 to that in 2006?
Offer a very short reply. 0.93. What is the ratio of the Emissions(kt) in Mali in 2003 to that in 2006?
Offer a very short reply. 0.89. What is the ratio of the Emissions(kt) of Venezuela in 2003 to that in 2006?
Ensure brevity in your answer.  1.32. What is the ratio of the Emissions(kt) of Bahrain in 2003 to that in 2007?
Your answer should be very brief. 0.67. What is the ratio of the Emissions(kt) of India in 2003 to that in 2007?
Ensure brevity in your answer.  0.91. What is the ratio of the Emissions(kt) of Mali in 2003 to that in 2007?
Give a very brief answer. 0.84. What is the ratio of the Emissions(kt) of Venezuela in 2003 to that in 2007?
Your answer should be compact. 1.49. What is the ratio of the Emissions(kt) of Bahrain in 2003 to that in 2008?
Ensure brevity in your answer.  0.58. What is the ratio of the Emissions(kt) in India in 2003 to that in 2008?
Ensure brevity in your answer.  0.74. What is the ratio of the Emissions(kt) in Mali in 2003 to that in 2008?
Ensure brevity in your answer.  0.79. What is the ratio of the Emissions(kt) in Venezuela in 2003 to that in 2008?
Offer a terse response. 1.19. What is the ratio of the Emissions(kt) of Bahrain in 2003 to that in 2009?
Provide a short and direct response. 1.04. What is the ratio of the Emissions(kt) in India in 2003 to that in 2009?
Ensure brevity in your answer.  0.66. What is the ratio of the Emissions(kt) in Mali in 2003 to that in 2009?
Provide a short and direct response. 0.73. What is the ratio of the Emissions(kt) in Venezuela in 2003 to that in 2009?
Keep it short and to the point. 1.16. What is the ratio of the Emissions(kt) of Bahrain in 2004 to that in 2005?
Make the answer very short. 0.81. What is the ratio of the Emissions(kt) of Mali in 2004 to that in 2005?
Your answer should be compact. 0.98. What is the ratio of the Emissions(kt) in Venezuela in 2004 to that in 2005?
Provide a succinct answer. 0.91. What is the ratio of the Emissions(kt) in Bahrain in 2004 to that in 2006?
Give a very brief answer. 1.24. What is the ratio of the Emissions(kt) of India in 2004 to that in 2006?
Your response must be concise. 0.94. What is the ratio of the Emissions(kt) of Venezuela in 2004 to that in 2006?
Offer a terse response. 0.9. What is the ratio of the Emissions(kt) of Bahrain in 2004 to that in 2007?
Your answer should be very brief. 0.74. What is the ratio of the Emissions(kt) in India in 2004 to that in 2007?
Offer a very short reply. 0.92. What is the ratio of the Emissions(kt) of Mali in 2004 to that in 2007?
Provide a short and direct response. 0.87. What is the ratio of the Emissions(kt) of Venezuela in 2004 to that in 2007?
Provide a short and direct response. 1.02. What is the ratio of the Emissions(kt) of Bahrain in 2004 to that in 2008?
Your answer should be very brief. 0.64. What is the ratio of the Emissions(kt) in India in 2004 to that in 2008?
Your answer should be very brief. 0.75. What is the ratio of the Emissions(kt) in Mali in 2004 to that in 2008?
Provide a succinct answer. 0.82. What is the ratio of the Emissions(kt) of Venezuela in 2004 to that in 2008?
Give a very brief answer. 0.82. What is the ratio of the Emissions(kt) in Bahrain in 2004 to that in 2009?
Ensure brevity in your answer.  1.16. What is the ratio of the Emissions(kt) in India in 2004 to that in 2009?
Offer a very short reply. 0.67. What is the ratio of the Emissions(kt) in Mali in 2004 to that in 2009?
Give a very brief answer. 0.76. What is the ratio of the Emissions(kt) of Venezuela in 2004 to that in 2009?
Ensure brevity in your answer.  0.8. What is the ratio of the Emissions(kt) in Bahrain in 2005 to that in 2006?
Keep it short and to the point. 1.53. What is the ratio of the Emissions(kt) in India in 2005 to that in 2006?
Provide a short and direct response. 0.95. What is the ratio of the Emissions(kt) in Mali in 2005 to that in 2006?
Ensure brevity in your answer.  0.95. What is the ratio of the Emissions(kt) of Venezuela in 2005 to that in 2006?
Offer a terse response. 0.99. What is the ratio of the Emissions(kt) of Bahrain in 2005 to that in 2007?
Give a very brief answer. 0.92. What is the ratio of the Emissions(kt) of India in 2005 to that in 2007?
Provide a succinct answer. 0.93. What is the ratio of the Emissions(kt) of Mali in 2005 to that in 2007?
Give a very brief answer. 0.89. What is the ratio of the Emissions(kt) in Venezuela in 2005 to that in 2007?
Ensure brevity in your answer.  1.12. What is the ratio of the Emissions(kt) in Bahrain in 2005 to that in 2008?
Give a very brief answer. 0.8. What is the ratio of the Emissions(kt) in India in 2005 to that in 2008?
Provide a succinct answer. 0.76. What is the ratio of the Emissions(kt) in Mali in 2005 to that in 2008?
Your response must be concise. 0.84. What is the ratio of the Emissions(kt) of Venezuela in 2005 to that in 2008?
Ensure brevity in your answer.  0.9. What is the ratio of the Emissions(kt) in Bahrain in 2005 to that in 2009?
Ensure brevity in your answer.  1.44. What is the ratio of the Emissions(kt) in India in 2005 to that in 2009?
Keep it short and to the point. 0.68. What is the ratio of the Emissions(kt) in Mali in 2005 to that in 2009?
Keep it short and to the point. 0.78. What is the ratio of the Emissions(kt) of Venezuela in 2005 to that in 2009?
Offer a terse response. 0.88. What is the ratio of the Emissions(kt) in Bahrain in 2006 to that in 2007?
Offer a terse response. 0.6. What is the ratio of the Emissions(kt) of India in 2006 to that in 2007?
Your response must be concise. 0.98. What is the ratio of the Emissions(kt) of Mali in 2006 to that in 2007?
Give a very brief answer. 0.93. What is the ratio of the Emissions(kt) of Venezuela in 2006 to that in 2007?
Offer a very short reply. 1.13. What is the ratio of the Emissions(kt) in Bahrain in 2006 to that in 2008?
Ensure brevity in your answer.  0.52. What is the ratio of the Emissions(kt) of India in 2006 to that in 2008?
Make the answer very short. 0.8. What is the ratio of the Emissions(kt) of Mali in 2006 to that in 2008?
Your response must be concise. 0.88. What is the ratio of the Emissions(kt) of Venezuela in 2006 to that in 2008?
Provide a succinct answer. 0.9. What is the ratio of the Emissions(kt) in Bahrain in 2006 to that in 2009?
Your response must be concise. 0.94. What is the ratio of the Emissions(kt) in India in 2006 to that in 2009?
Give a very brief answer. 0.71. What is the ratio of the Emissions(kt) of Mali in 2006 to that in 2009?
Ensure brevity in your answer.  0.82. What is the ratio of the Emissions(kt) of Venezuela in 2006 to that in 2009?
Provide a succinct answer. 0.88. What is the ratio of the Emissions(kt) of Bahrain in 2007 to that in 2008?
Offer a terse response. 0.87. What is the ratio of the Emissions(kt) in India in 2007 to that in 2008?
Provide a succinct answer. 0.82. What is the ratio of the Emissions(kt) in Mali in 2007 to that in 2008?
Provide a succinct answer. 0.94. What is the ratio of the Emissions(kt) of Venezuela in 2007 to that in 2008?
Make the answer very short. 0.8. What is the ratio of the Emissions(kt) of Bahrain in 2007 to that in 2009?
Give a very brief answer. 1.57. What is the ratio of the Emissions(kt) in India in 2007 to that in 2009?
Keep it short and to the point. 0.73. What is the ratio of the Emissions(kt) in Mali in 2007 to that in 2009?
Provide a short and direct response. 0.88. What is the ratio of the Emissions(kt) in Venezuela in 2007 to that in 2009?
Offer a very short reply. 0.78. What is the ratio of the Emissions(kt) of Bahrain in 2008 to that in 2009?
Your answer should be very brief. 1.81. What is the ratio of the Emissions(kt) of India in 2008 to that in 2009?
Your response must be concise. 0.89. What is the ratio of the Emissions(kt) in Mali in 2008 to that in 2009?
Keep it short and to the point. 0.93. What is the ratio of the Emissions(kt) in Venezuela in 2008 to that in 2009?
Offer a terse response. 0.98. What is the difference between the highest and the second highest Emissions(kt) of Bahrain?
Make the answer very short. 784.74. What is the difference between the highest and the second highest Emissions(kt) in India?
Your answer should be very brief. 4.88e+04. What is the difference between the highest and the second highest Emissions(kt) of Mali?
Offer a very short reply. 77.01. What is the difference between the highest and the second highest Emissions(kt) of Venezuela?
Provide a short and direct response. 1.77e+04. What is the difference between the highest and the lowest Emissions(kt) in Bahrain?
Provide a short and direct response. 2838.26. What is the difference between the highest and the lowest Emissions(kt) in India?
Make the answer very short. 1.50e+05. What is the difference between the highest and the lowest Emissions(kt) of Mali?
Give a very brief answer. 304.36. What is the difference between the highest and the lowest Emissions(kt) in Venezuela?
Provide a short and direct response. 4.17e+04. 